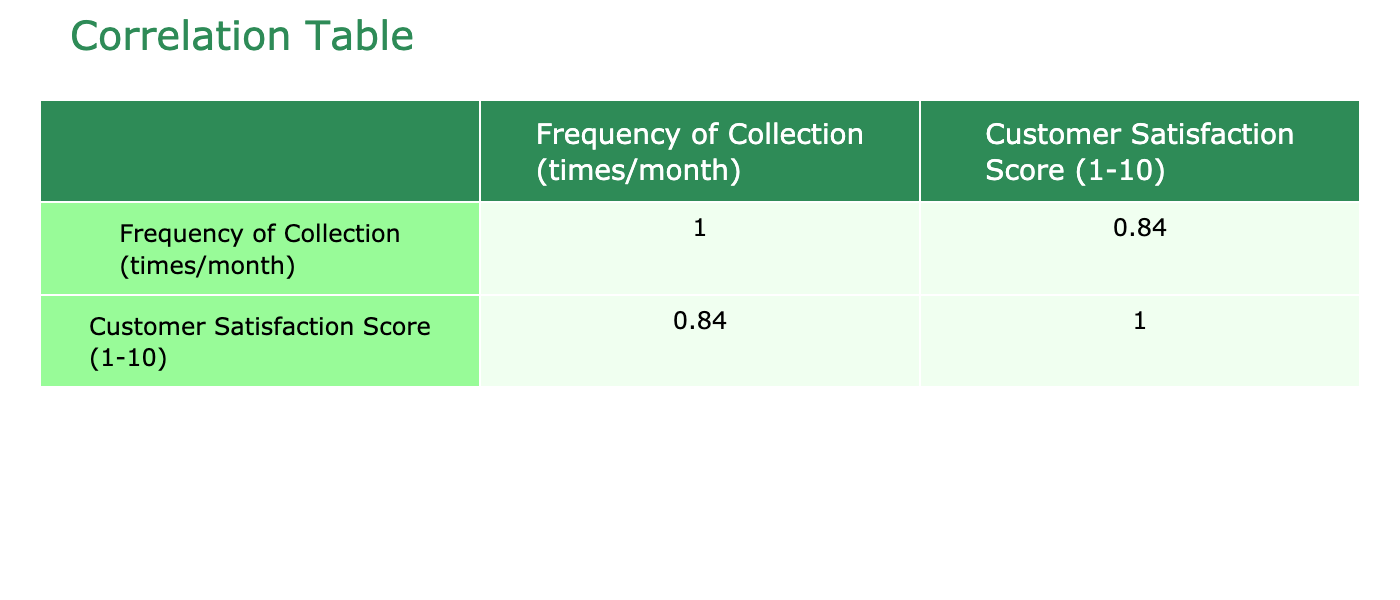What is the highest Customer Satisfaction Score recorded in the table? By examining the 'Customer Satisfaction Score (1-10)' column, the highest score is 9. This score appears for Clean Planet Disposal and EcoRecycle Corp.
Answer: 9 What is the frequency of collection for WasteNot? Looking at the 'Frequency of Collection (times/month)' column, WasteNot is listed with a frequency of 3 times per month.
Answer: 3 Is there any customer with a satisfaction score lower than 5? By scanning the ‘Customer Satisfaction Score (1-10)’ column, the lowest score is 4, recorded for Renewed Paper. This indicates that there is indeed a customer with a satisfaction score lower than 5.
Answer: Yes What is the average frequency of collection for all customers in the table? To compute the average frequency, sum the values in the 'Frequency of Collection (times/month)' column: (3 + 5 + 4 + 2 + 6 + 3 + 4 + 1 + 5 + 2) = 35. There are 10 customers, so the average frequency is 35/10 = 3.5.
Answer: 3.5 Which customer has the same satisfaction score as their frequency of collection? By comparing both columns, only Reclaim Resources has a frequency of 4 times per month and a satisfaction score of 8. None of the other customers have matching numbers.
Answer: Reclaim Resources What is the difference in Customer Satisfaction Score between the customer with the highest collection frequency and the one with the lowest? Clean Planet Disposal has the highest frequency of 6 with a satisfaction score of 9, while Renewed Paper, with the lowest frequency of 1, has a score of 4. The difference is 9 - 4 = 5.
Answer: 5 Which customer has the lowest frequency of collection? Scan the 'Frequency of Collection (times/month)' column to find that Renewed Paper has the lowest frequency with just 1 time per month.
Answer: Renewed Paper What is the range of Customer Satisfaction Scores? The range is calculated by finding the difference between the highest and lowest scores. The highest score is 9 (from Clean Planet Disposal and EcoRecycle Corp) and the lowest is 4 (from Renewed Paper). Therefore, the range is 9 - 4 = 5.
Answer: 5 Is the Customer Satisfaction Score correlated positively with the Frequency of Collection? To determine this, we check the correlation coefficient in the correlation table. A positive correlation would indicate that as the frequency increases, the satisfaction score also tends to increase. Here, the correlation coefficient for both variables is expected to reflect a positive relationship.
Answer: Yes 